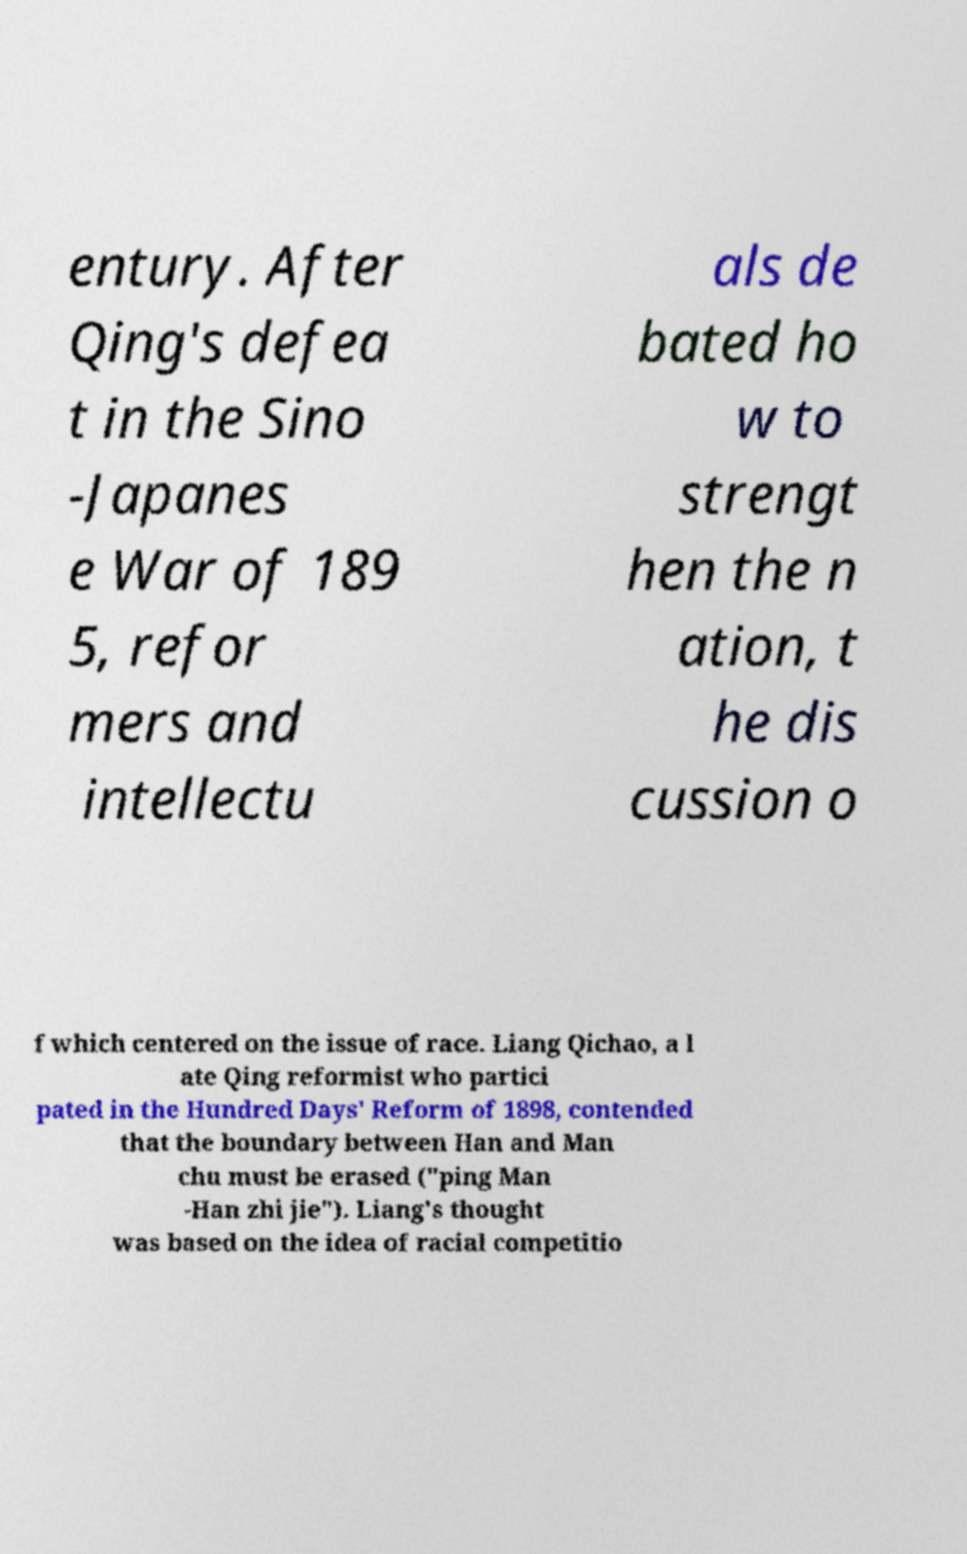Can you accurately transcribe the text from the provided image for me? entury. After Qing's defea t in the Sino -Japanes e War of 189 5, refor mers and intellectu als de bated ho w to strengt hen the n ation, t he dis cussion o f which centered on the issue of race. Liang Qichao, a l ate Qing reformist who partici pated in the Hundred Days' Reform of 1898, contended that the boundary between Han and Man chu must be erased ("ping Man -Han zhi jie"). Liang's thought was based on the idea of racial competitio 